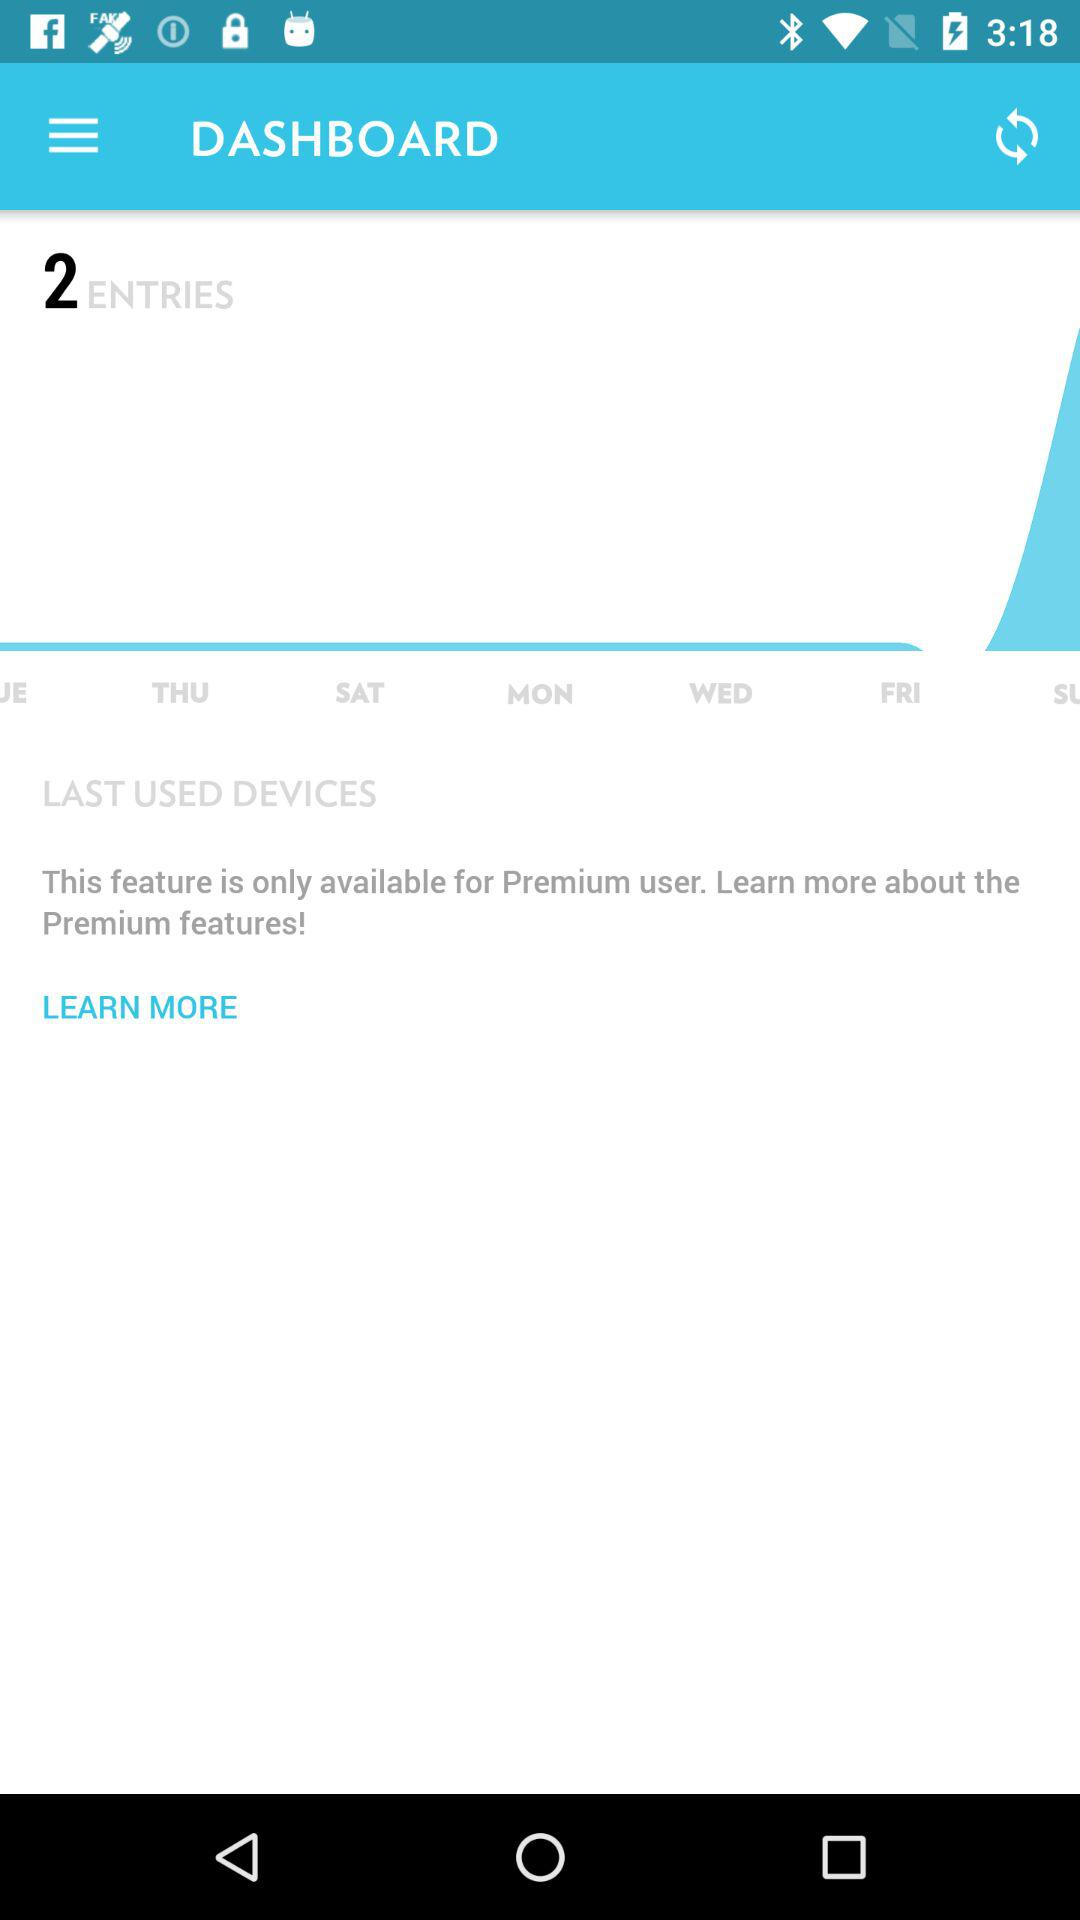How many entries are there in total?
Answer the question using a single word or phrase. 2 